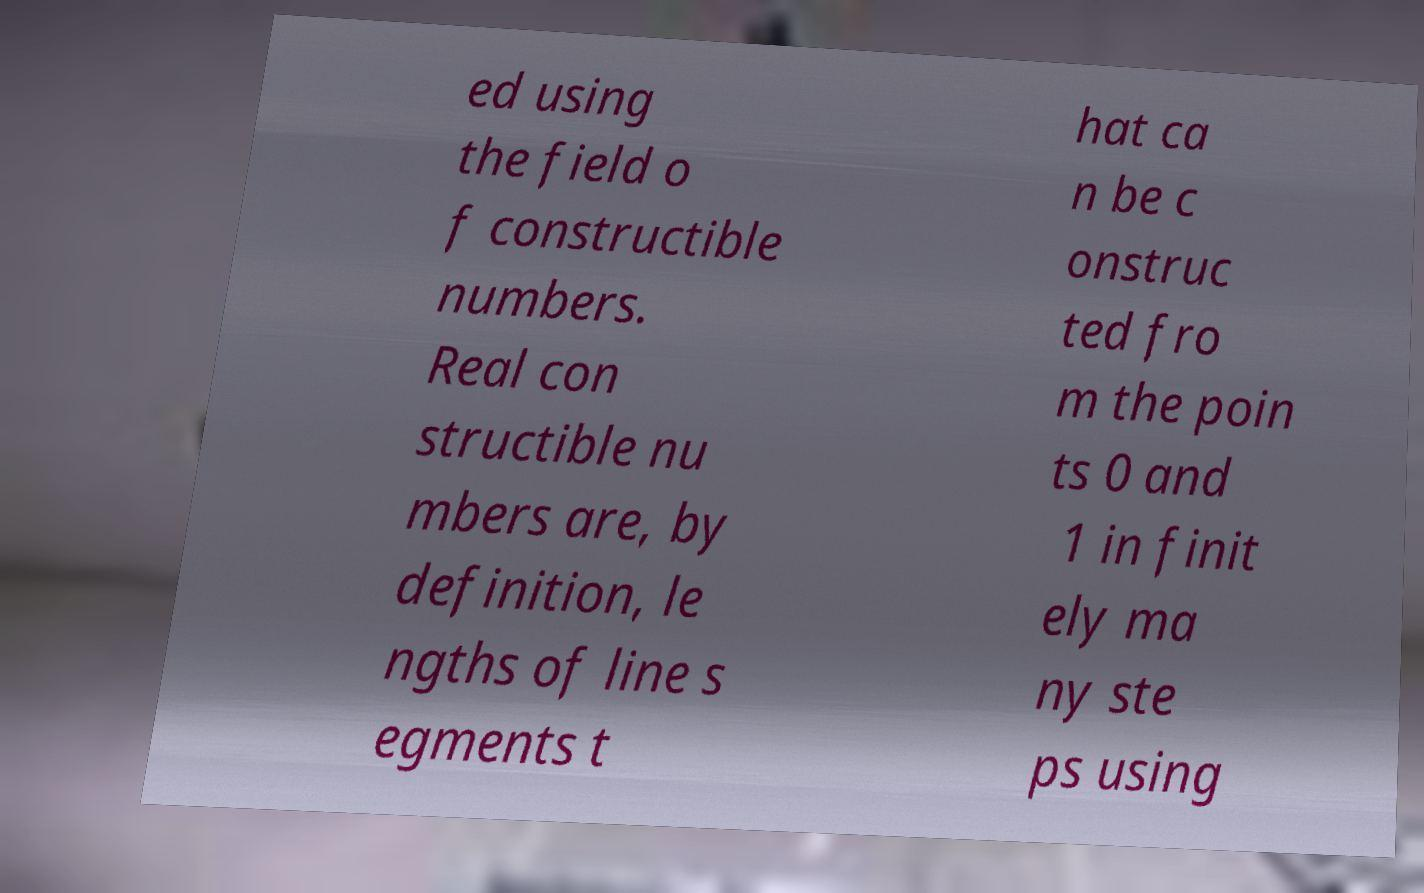Could you extract and type out the text from this image? ed using the field o f constructible numbers. Real con structible nu mbers are, by definition, le ngths of line s egments t hat ca n be c onstruc ted fro m the poin ts 0 and 1 in finit ely ma ny ste ps using 